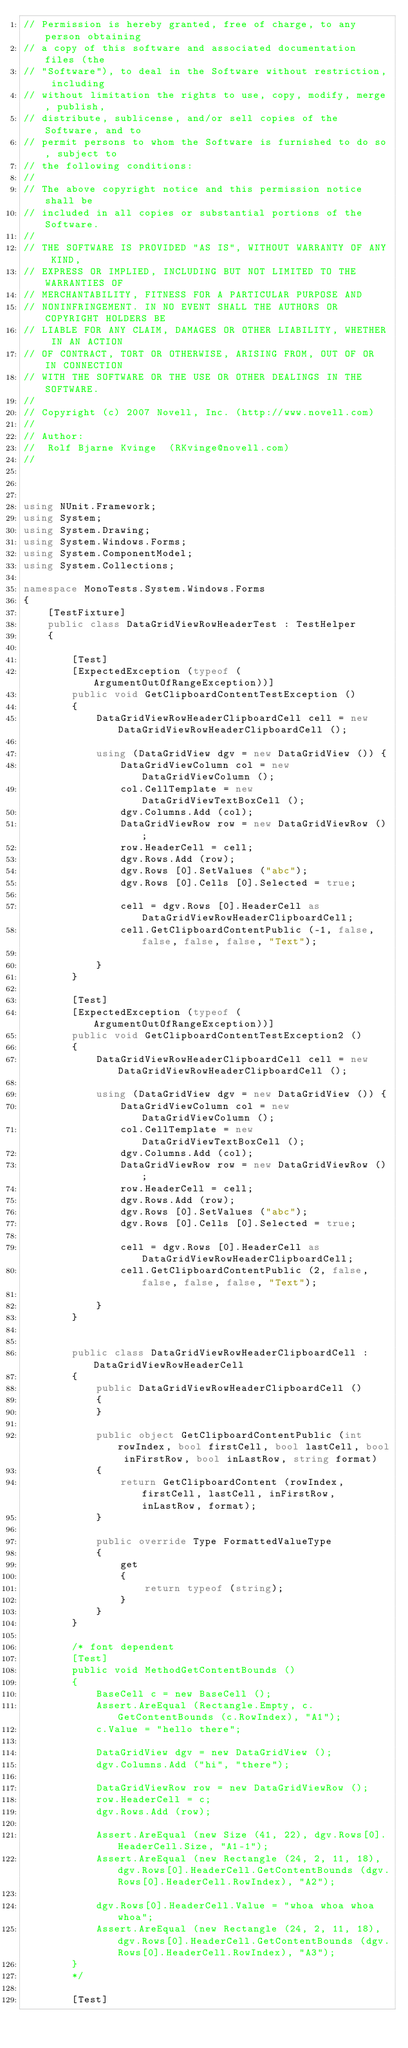Convert code to text. <code><loc_0><loc_0><loc_500><loc_500><_C#_>// Permission is hereby granted, free of charge, to any person obtaining
// a copy of this software and associated documentation files (the
// "Software"), to deal in the Software without restriction, including
// without limitation the rights to use, copy, modify, merge, publish,
// distribute, sublicense, and/or sell copies of the Software, and to
// permit persons to whom the Software is furnished to do so, subject to
// the following conditions:
// 
// The above copyright notice and this permission notice shall be
// included in all copies or substantial portions of the Software.
// 
// THE SOFTWARE IS PROVIDED "AS IS", WITHOUT WARRANTY OF ANY KIND,
// EXPRESS OR IMPLIED, INCLUDING BUT NOT LIMITED TO THE WARRANTIES OF
// MERCHANTABILITY, FITNESS FOR A PARTICULAR PURPOSE AND
// NONINFRINGEMENT. IN NO EVENT SHALL THE AUTHORS OR COPYRIGHT HOLDERS BE
// LIABLE FOR ANY CLAIM, DAMAGES OR OTHER LIABILITY, WHETHER IN AN ACTION
// OF CONTRACT, TORT OR OTHERWISE, ARISING FROM, OUT OF OR IN CONNECTION
// WITH THE SOFTWARE OR THE USE OR OTHER DEALINGS IN THE SOFTWARE.
//
// Copyright (c) 2007 Novell, Inc. (http://www.novell.com)
//
// Author:
//	Rolf Bjarne Kvinge  (RKvinge@novell.com)
//



using NUnit.Framework;
using System;
using System.Drawing;
using System.Windows.Forms;
using System.ComponentModel;
using System.Collections;

namespace MonoTests.System.Windows.Forms
{
	[TestFixture]
	public class DataGridViewRowHeaderTest : TestHelper
	{

		[Test]
		[ExpectedException (typeof (ArgumentOutOfRangeException))]
		public void GetClipboardContentTestException ()
		{
			DataGridViewRowHeaderClipboardCell cell = new DataGridViewRowHeaderClipboardCell ();
			
			using (DataGridView dgv = new DataGridView ()) {
				DataGridViewColumn col = new DataGridViewColumn ();
				col.CellTemplate = new DataGridViewTextBoxCell ();
				dgv.Columns.Add (col);
				DataGridViewRow row = new DataGridViewRow ();
				row.HeaderCell = cell;
				dgv.Rows.Add (row);
				dgv.Rows [0].SetValues ("abc");
				dgv.Rows [0].Cells [0].Selected = true;

				cell = dgv.Rows [0].HeaderCell as DataGridViewRowHeaderClipboardCell;
				cell.GetClipboardContentPublic (-1, false, false, false, false, "Text");

			}
		}

		[Test]
		[ExpectedException (typeof (ArgumentOutOfRangeException))]
		public void GetClipboardContentTestException2 ()
		{
			DataGridViewRowHeaderClipboardCell cell = new DataGridViewRowHeaderClipboardCell ();

			using (DataGridView dgv = new DataGridView ()) {
				DataGridViewColumn col = new DataGridViewColumn ();
				col.CellTemplate = new DataGridViewTextBoxCell ();
				dgv.Columns.Add (col);
				DataGridViewRow row = new DataGridViewRow ();
				row.HeaderCell = cell;
				dgv.Rows.Add (row);
				dgv.Rows [0].SetValues ("abc");
				dgv.Rows [0].Cells [0].Selected = true;

				cell = dgv.Rows [0].HeaderCell as DataGridViewRowHeaderClipboardCell;
				cell.GetClipboardContentPublic (2, false, false, false, false, "Text");

			}
		}
		
		
		public class DataGridViewRowHeaderClipboardCell : DataGridViewRowHeaderCell
		{
			public DataGridViewRowHeaderClipboardCell ()
			{
			}

			public object GetClipboardContentPublic (int rowIndex, bool firstCell, bool lastCell, bool inFirstRow, bool inLastRow, string format)
			{
				return GetClipboardContent (rowIndex, firstCell, lastCell, inFirstRow, inLastRow, format);
			}

			public override Type FormattedValueType
			{
				get
				{
					return typeof (string);
				}
			}
		}

		/* font dependent
		[Test]
		public void MethodGetContentBounds ()
		{
			BaseCell c = new BaseCell ();
			Assert.AreEqual (Rectangle.Empty, c.GetContentBounds (c.RowIndex), "A1");
			c.Value = "hello there";
			
			DataGridView dgv = new DataGridView ();
			dgv.Columns.Add ("hi", "there");

			DataGridViewRow row = new DataGridViewRow ();
			row.HeaderCell = c;
			dgv.Rows.Add (row);

			Assert.AreEqual (new Size (41, 22), dgv.Rows[0].HeaderCell.Size, "A1-1");
			Assert.AreEqual (new Rectangle (24, 2, 11, 18), dgv.Rows[0].HeaderCell.GetContentBounds (dgv.Rows[0].HeaderCell.RowIndex), "A2");

			dgv.Rows[0].HeaderCell.Value = "whoa whoa whoa whoa";
			Assert.AreEqual (new Rectangle (24, 2, 11, 18), dgv.Rows[0].HeaderCell.GetContentBounds (dgv.Rows[0].HeaderCell.RowIndex), "A3");
		}
		*/
		
		[Test]</code> 